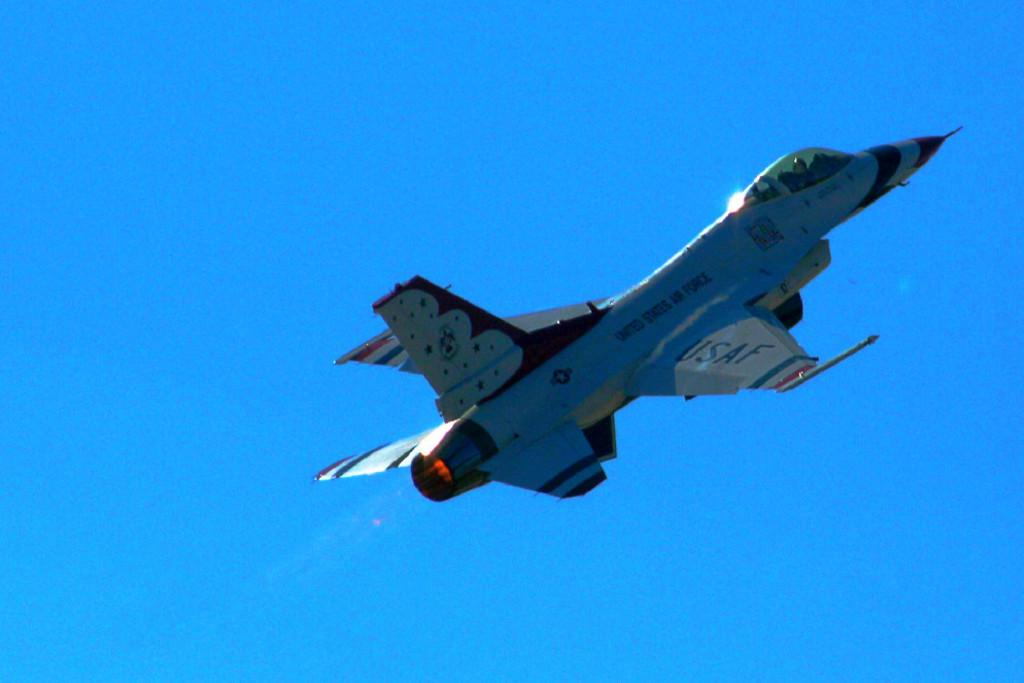<image>
Relay a brief, clear account of the picture shown. a USAF fighter plane taking off into the air 